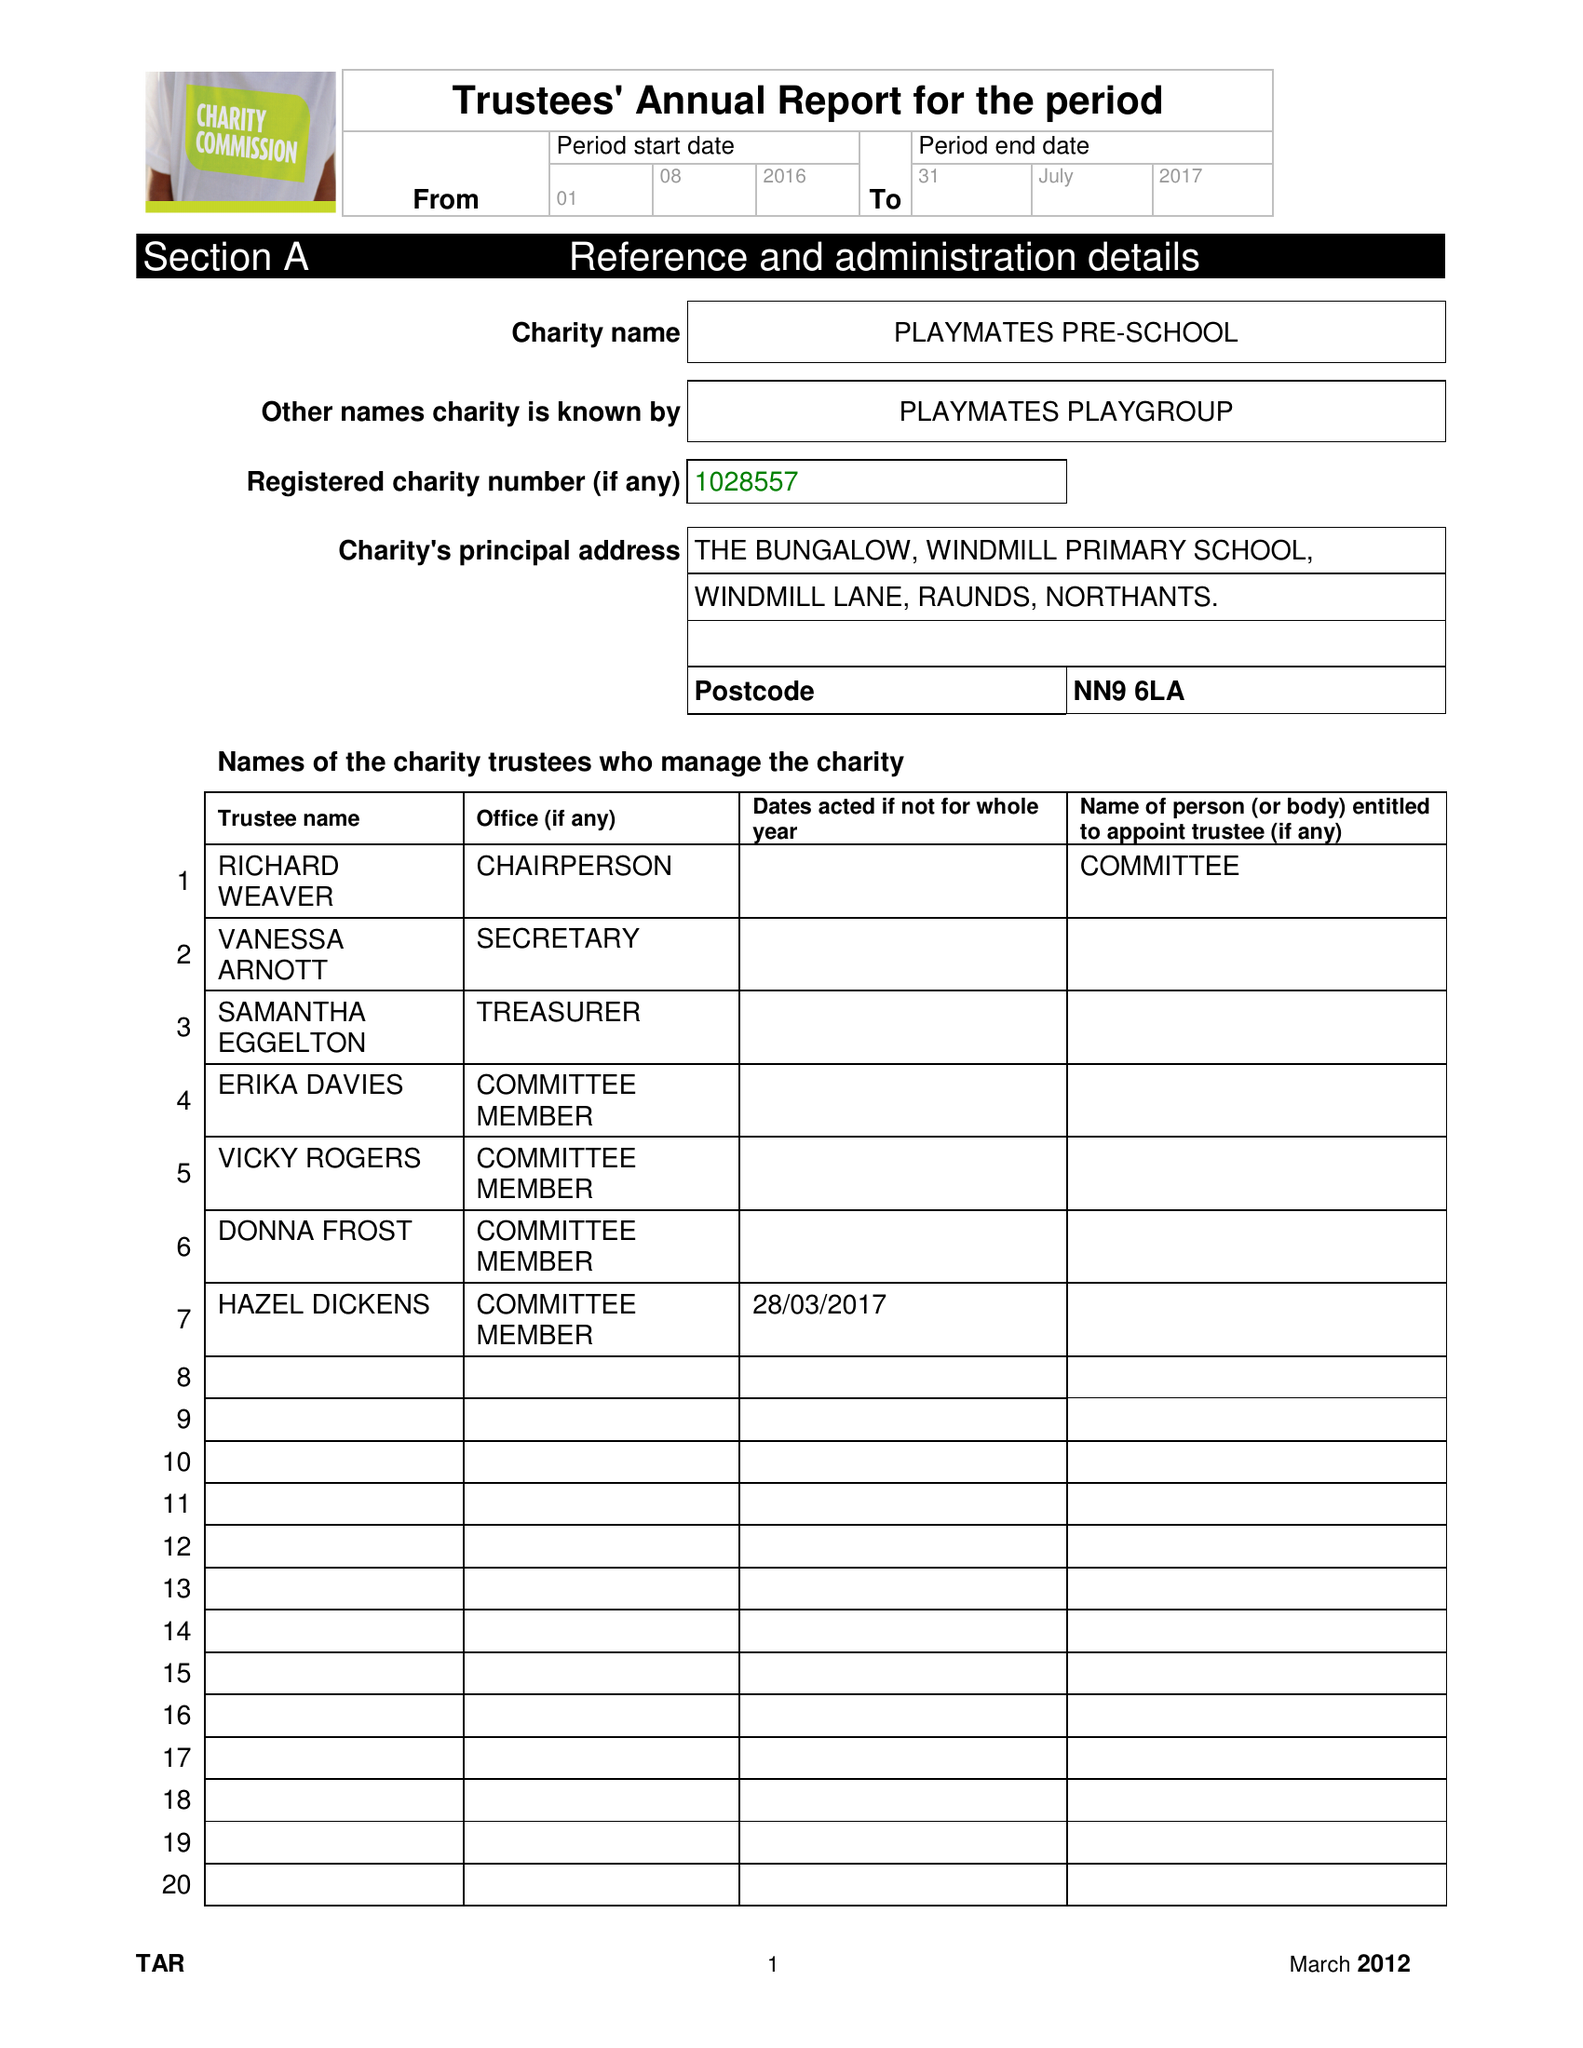What is the value for the spending_annually_in_british_pounds?
Answer the question using a single word or phrase. 94172.81 